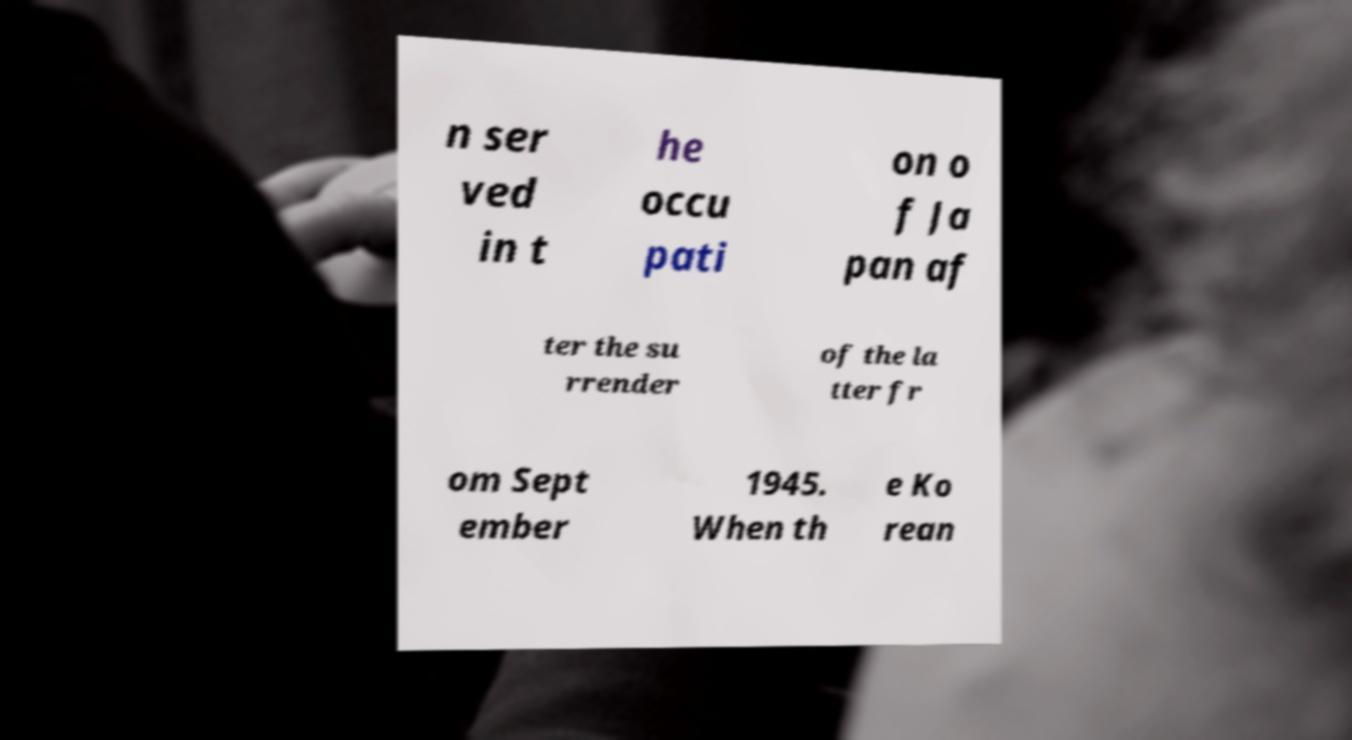Can you accurately transcribe the text from the provided image for me? n ser ved in t he occu pati on o f Ja pan af ter the su rrender of the la tter fr om Sept ember 1945. When th e Ko rean 